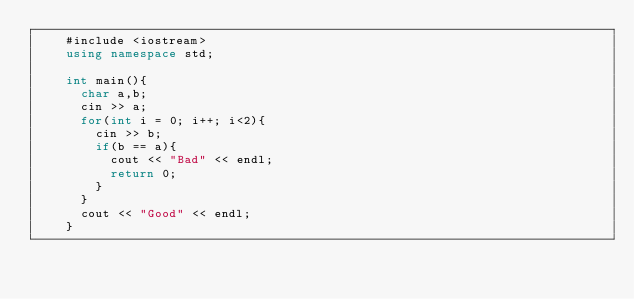<code> <loc_0><loc_0><loc_500><loc_500><_C++_>    #include <iostream>
    using namespace std;
     
    int main(){
      char a,b;
      cin >> a;
      for(int i = 0; i++; i<2){
        cin >> b;
        if(b == a){
          cout << "Bad" << endl;
          return 0;
        }
      }
      cout << "Good" << endl;
    }</code> 